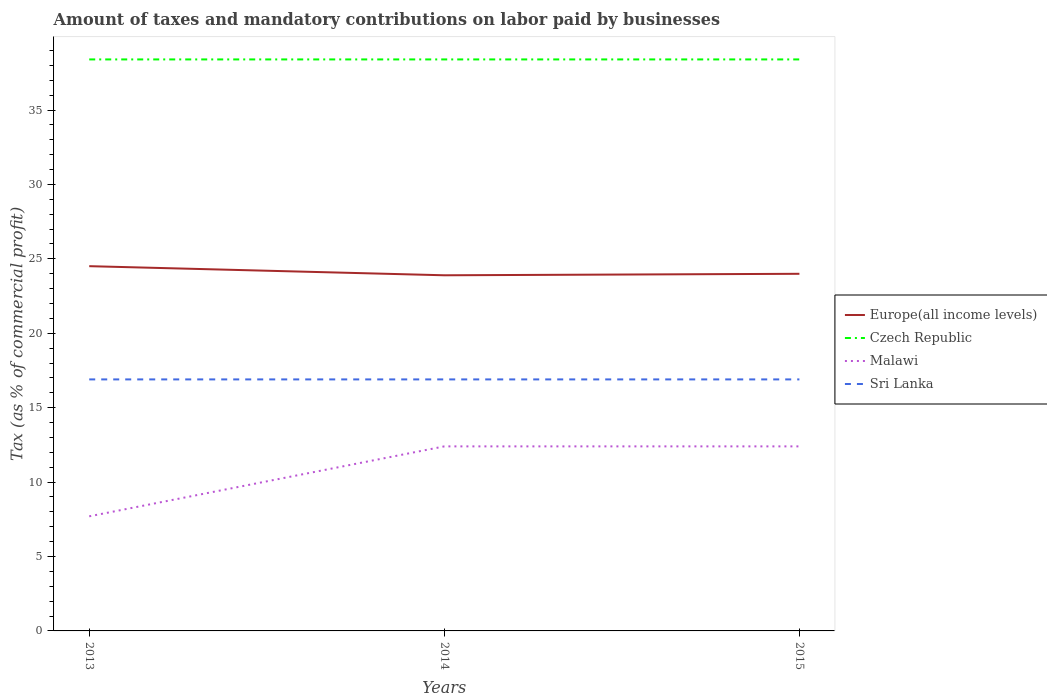Does the line corresponding to Europe(all income levels) intersect with the line corresponding to Sri Lanka?
Your response must be concise. No. Is the number of lines equal to the number of legend labels?
Your answer should be very brief. Yes. Across all years, what is the maximum percentage of taxes paid by businesses in Europe(all income levels)?
Provide a succinct answer. 23.9. What is the total percentage of taxes paid by businesses in Czech Republic in the graph?
Your response must be concise. 0. What is the difference between the highest and the second highest percentage of taxes paid by businesses in Czech Republic?
Ensure brevity in your answer.  0. How many years are there in the graph?
Make the answer very short. 3. What is the difference between two consecutive major ticks on the Y-axis?
Offer a terse response. 5. Are the values on the major ticks of Y-axis written in scientific E-notation?
Provide a succinct answer. No. Does the graph contain grids?
Provide a succinct answer. No. How are the legend labels stacked?
Your response must be concise. Vertical. What is the title of the graph?
Offer a very short reply. Amount of taxes and mandatory contributions on labor paid by businesses. Does "Cambodia" appear as one of the legend labels in the graph?
Your answer should be compact. No. What is the label or title of the Y-axis?
Provide a short and direct response. Tax (as % of commercial profit). What is the Tax (as % of commercial profit) in Europe(all income levels) in 2013?
Your response must be concise. 24.51. What is the Tax (as % of commercial profit) in Czech Republic in 2013?
Ensure brevity in your answer.  38.4. What is the Tax (as % of commercial profit) of Malawi in 2013?
Provide a succinct answer. 7.7. What is the Tax (as % of commercial profit) in Europe(all income levels) in 2014?
Offer a very short reply. 23.9. What is the Tax (as % of commercial profit) in Czech Republic in 2014?
Keep it short and to the point. 38.4. What is the Tax (as % of commercial profit) in Malawi in 2014?
Keep it short and to the point. 12.4. What is the Tax (as % of commercial profit) in Sri Lanka in 2014?
Give a very brief answer. 16.9. What is the Tax (as % of commercial profit) in Europe(all income levels) in 2015?
Ensure brevity in your answer.  24. What is the Tax (as % of commercial profit) of Czech Republic in 2015?
Give a very brief answer. 38.4. What is the Tax (as % of commercial profit) in Sri Lanka in 2015?
Make the answer very short. 16.9. Across all years, what is the maximum Tax (as % of commercial profit) of Europe(all income levels)?
Offer a very short reply. 24.51. Across all years, what is the maximum Tax (as % of commercial profit) in Czech Republic?
Your answer should be compact. 38.4. Across all years, what is the maximum Tax (as % of commercial profit) of Sri Lanka?
Ensure brevity in your answer.  16.9. Across all years, what is the minimum Tax (as % of commercial profit) in Europe(all income levels)?
Your answer should be very brief. 23.9. Across all years, what is the minimum Tax (as % of commercial profit) in Czech Republic?
Provide a short and direct response. 38.4. Across all years, what is the minimum Tax (as % of commercial profit) of Sri Lanka?
Provide a short and direct response. 16.9. What is the total Tax (as % of commercial profit) of Europe(all income levels) in the graph?
Provide a short and direct response. 72.4. What is the total Tax (as % of commercial profit) of Czech Republic in the graph?
Keep it short and to the point. 115.2. What is the total Tax (as % of commercial profit) of Malawi in the graph?
Keep it short and to the point. 32.5. What is the total Tax (as % of commercial profit) of Sri Lanka in the graph?
Your answer should be very brief. 50.7. What is the difference between the Tax (as % of commercial profit) in Europe(all income levels) in 2013 and that in 2014?
Make the answer very short. 0.61. What is the difference between the Tax (as % of commercial profit) in Czech Republic in 2013 and that in 2014?
Provide a succinct answer. 0. What is the difference between the Tax (as % of commercial profit) in Sri Lanka in 2013 and that in 2014?
Your response must be concise. 0. What is the difference between the Tax (as % of commercial profit) of Europe(all income levels) in 2013 and that in 2015?
Provide a succinct answer. 0.51. What is the difference between the Tax (as % of commercial profit) of Czech Republic in 2013 and that in 2015?
Your answer should be very brief. 0. What is the difference between the Tax (as % of commercial profit) of Europe(all income levels) in 2014 and that in 2015?
Offer a terse response. -0.1. What is the difference between the Tax (as % of commercial profit) in Malawi in 2014 and that in 2015?
Make the answer very short. 0. What is the difference between the Tax (as % of commercial profit) of Sri Lanka in 2014 and that in 2015?
Keep it short and to the point. 0. What is the difference between the Tax (as % of commercial profit) in Europe(all income levels) in 2013 and the Tax (as % of commercial profit) in Czech Republic in 2014?
Ensure brevity in your answer.  -13.89. What is the difference between the Tax (as % of commercial profit) of Europe(all income levels) in 2013 and the Tax (as % of commercial profit) of Malawi in 2014?
Provide a short and direct response. 12.11. What is the difference between the Tax (as % of commercial profit) of Europe(all income levels) in 2013 and the Tax (as % of commercial profit) of Sri Lanka in 2014?
Your response must be concise. 7.61. What is the difference between the Tax (as % of commercial profit) in Czech Republic in 2013 and the Tax (as % of commercial profit) in Malawi in 2014?
Your answer should be compact. 26. What is the difference between the Tax (as % of commercial profit) of Czech Republic in 2013 and the Tax (as % of commercial profit) of Sri Lanka in 2014?
Provide a short and direct response. 21.5. What is the difference between the Tax (as % of commercial profit) of Europe(all income levels) in 2013 and the Tax (as % of commercial profit) of Czech Republic in 2015?
Provide a succinct answer. -13.89. What is the difference between the Tax (as % of commercial profit) of Europe(all income levels) in 2013 and the Tax (as % of commercial profit) of Malawi in 2015?
Your answer should be compact. 12.11. What is the difference between the Tax (as % of commercial profit) in Europe(all income levels) in 2013 and the Tax (as % of commercial profit) in Sri Lanka in 2015?
Your answer should be compact. 7.61. What is the difference between the Tax (as % of commercial profit) of Czech Republic in 2013 and the Tax (as % of commercial profit) of Malawi in 2015?
Your answer should be very brief. 26. What is the difference between the Tax (as % of commercial profit) of Europe(all income levels) in 2014 and the Tax (as % of commercial profit) of Czech Republic in 2015?
Offer a terse response. -14.5. What is the difference between the Tax (as % of commercial profit) in Europe(all income levels) in 2014 and the Tax (as % of commercial profit) in Malawi in 2015?
Make the answer very short. 11.5. What is the difference between the Tax (as % of commercial profit) of Europe(all income levels) in 2014 and the Tax (as % of commercial profit) of Sri Lanka in 2015?
Your answer should be compact. 7. What is the difference between the Tax (as % of commercial profit) in Malawi in 2014 and the Tax (as % of commercial profit) in Sri Lanka in 2015?
Your answer should be compact. -4.5. What is the average Tax (as % of commercial profit) of Europe(all income levels) per year?
Provide a short and direct response. 24.13. What is the average Tax (as % of commercial profit) of Czech Republic per year?
Your answer should be compact. 38.4. What is the average Tax (as % of commercial profit) in Malawi per year?
Give a very brief answer. 10.83. What is the average Tax (as % of commercial profit) in Sri Lanka per year?
Your answer should be compact. 16.9. In the year 2013, what is the difference between the Tax (as % of commercial profit) in Europe(all income levels) and Tax (as % of commercial profit) in Czech Republic?
Your response must be concise. -13.89. In the year 2013, what is the difference between the Tax (as % of commercial profit) of Europe(all income levels) and Tax (as % of commercial profit) of Malawi?
Your answer should be compact. 16.81. In the year 2013, what is the difference between the Tax (as % of commercial profit) in Europe(all income levels) and Tax (as % of commercial profit) in Sri Lanka?
Your answer should be compact. 7.61. In the year 2013, what is the difference between the Tax (as % of commercial profit) in Czech Republic and Tax (as % of commercial profit) in Malawi?
Your response must be concise. 30.7. In the year 2014, what is the difference between the Tax (as % of commercial profit) in Europe(all income levels) and Tax (as % of commercial profit) in Czech Republic?
Offer a very short reply. -14.5. In the year 2014, what is the difference between the Tax (as % of commercial profit) of Europe(all income levels) and Tax (as % of commercial profit) of Malawi?
Give a very brief answer. 11.5. In the year 2014, what is the difference between the Tax (as % of commercial profit) of Europe(all income levels) and Tax (as % of commercial profit) of Sri Lanka?
Make the answer very short. 7. In the year 2014, what is the difference between the Tax (as % of commercial profit) in Czech Republic and Tax (as % of commercial profit) in Malawi?
Make the answer very short. 26. In the year 2014, what is the difference between the Tax (as % of commercial profit) in Malawi and Tax (as % of commercial profit) in Sri Lanka?
Provide a succinct answer. -4.5. In the year 2015, what is the difference between the Tax (as % of commercial profit) of Europe(all income levels) and Tax (as % of commercial profit) of Czech Republic?
Your answer should be compact. -14.4. In the year 2015, what is the difference between the Tax (as % of commercial profit) of Europe(all income levels) and Tax (as % of commercial profit) of Malawi?
Your response must be concise. 11.6. In the year 2015, what is the difference between the Tax (as % of commercial profit) in Europe(all income levels) and Tax (as % of commercial profit) in Sri Lanka?
Your answer should be very brief. 7.1. In the year 2015, what is the difference between the Tax (as % of commercial profit) of Czech Republic and Tax (as % of commercial profit) of Malawi?
Give a very brief answer. 26. In the year 2015, what is the difference between the Tax (as % of commercial profit) in Czech Republic and Tax (as % of commercial profit) in Sri Lanka?
Provide a succinct answer. 21.5. In the year 2015, what is the difference between the Tax (as % of commercial profit) of Malawi and Tax (as % of commercial profit) of Sri Lanka?
Make the answer very short. -4.5. What is the ratio of the Tax (as % of commercial profit) in Europe(all income levels) in 2013 to that in 2014?
Offer a terse response. 1.03. What is the ratio of the Tax (as % of commercial profit) of Czech Republic in 2013 to that in 2014?
Ensure brevity in your answer.  1. What is the ratio of the Tax (as % of commercial profit) of Malawi in 2013 to that in 2014?
Give a very brief answer. 0.62. What is the ratio of the Tax (as % of commercial profit) in Europe(all income levels) in 2013 to that in 2015?
Your answer should be very brief. 1.02. What is the ratio of the Tax (as % of commercial profit) in Malawi in 2013 to that in 2015?
Offer a terse response. 0.62. What is the ratio of the Tax (as % of commercial profit) in Europe(all income levels) in 2014 to that in 2015?
Provide a short and direct response. 1. What is the ratio of the Tax (as % of commercial profit) in Malawi in 2014 to that in 2015?
Your answer should be very brief. 1. What is the difference between the highest and the second highest Tax (as % of commercial profit) in Europe(all income levels)?
Offer a terse response. 0.51. What is the difference between the highest and the second highest Tax (as % of commercial profit) in Czech Republic?
Your answer should be compact. 0. What is the difference between the highest and the lowest Tax (as % of commercial profit) of Europe(all income levels)?
Your answer should be very brief. 0.61. What is the difference between the highest and the lowest Tax (as % of commercial profit) of Malawi?
Your answer should be compact. 4.7. 